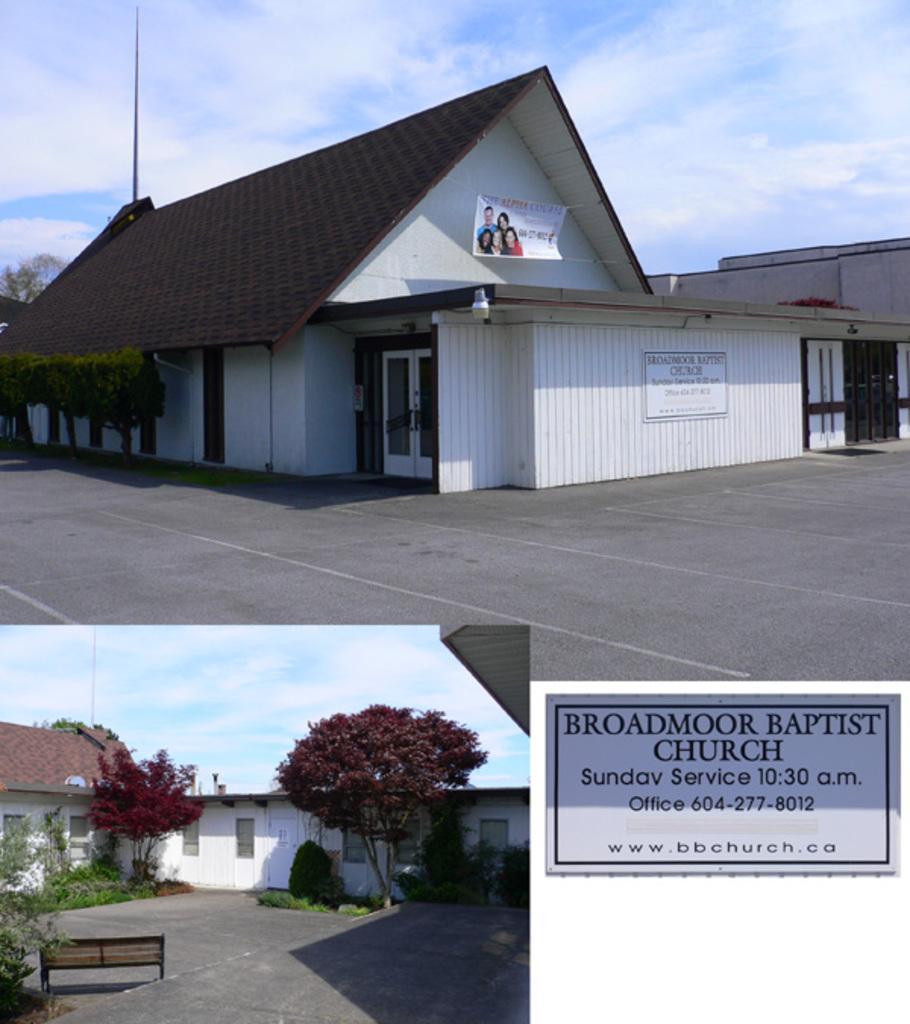In one or two sentences, can you explain what this image depicts? In this picture I can observe three images. In two images I can observe houses and trees. In the third image I can observe a board which is in grey color. There is some text on the board. I can observe a sky in the background in two images. 